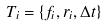<formula> <loc_0><loc_0><loc_500><loc_500>T _ { i } = \{ f _ { i } , r _ { i } , \Delta t \}</formula> 